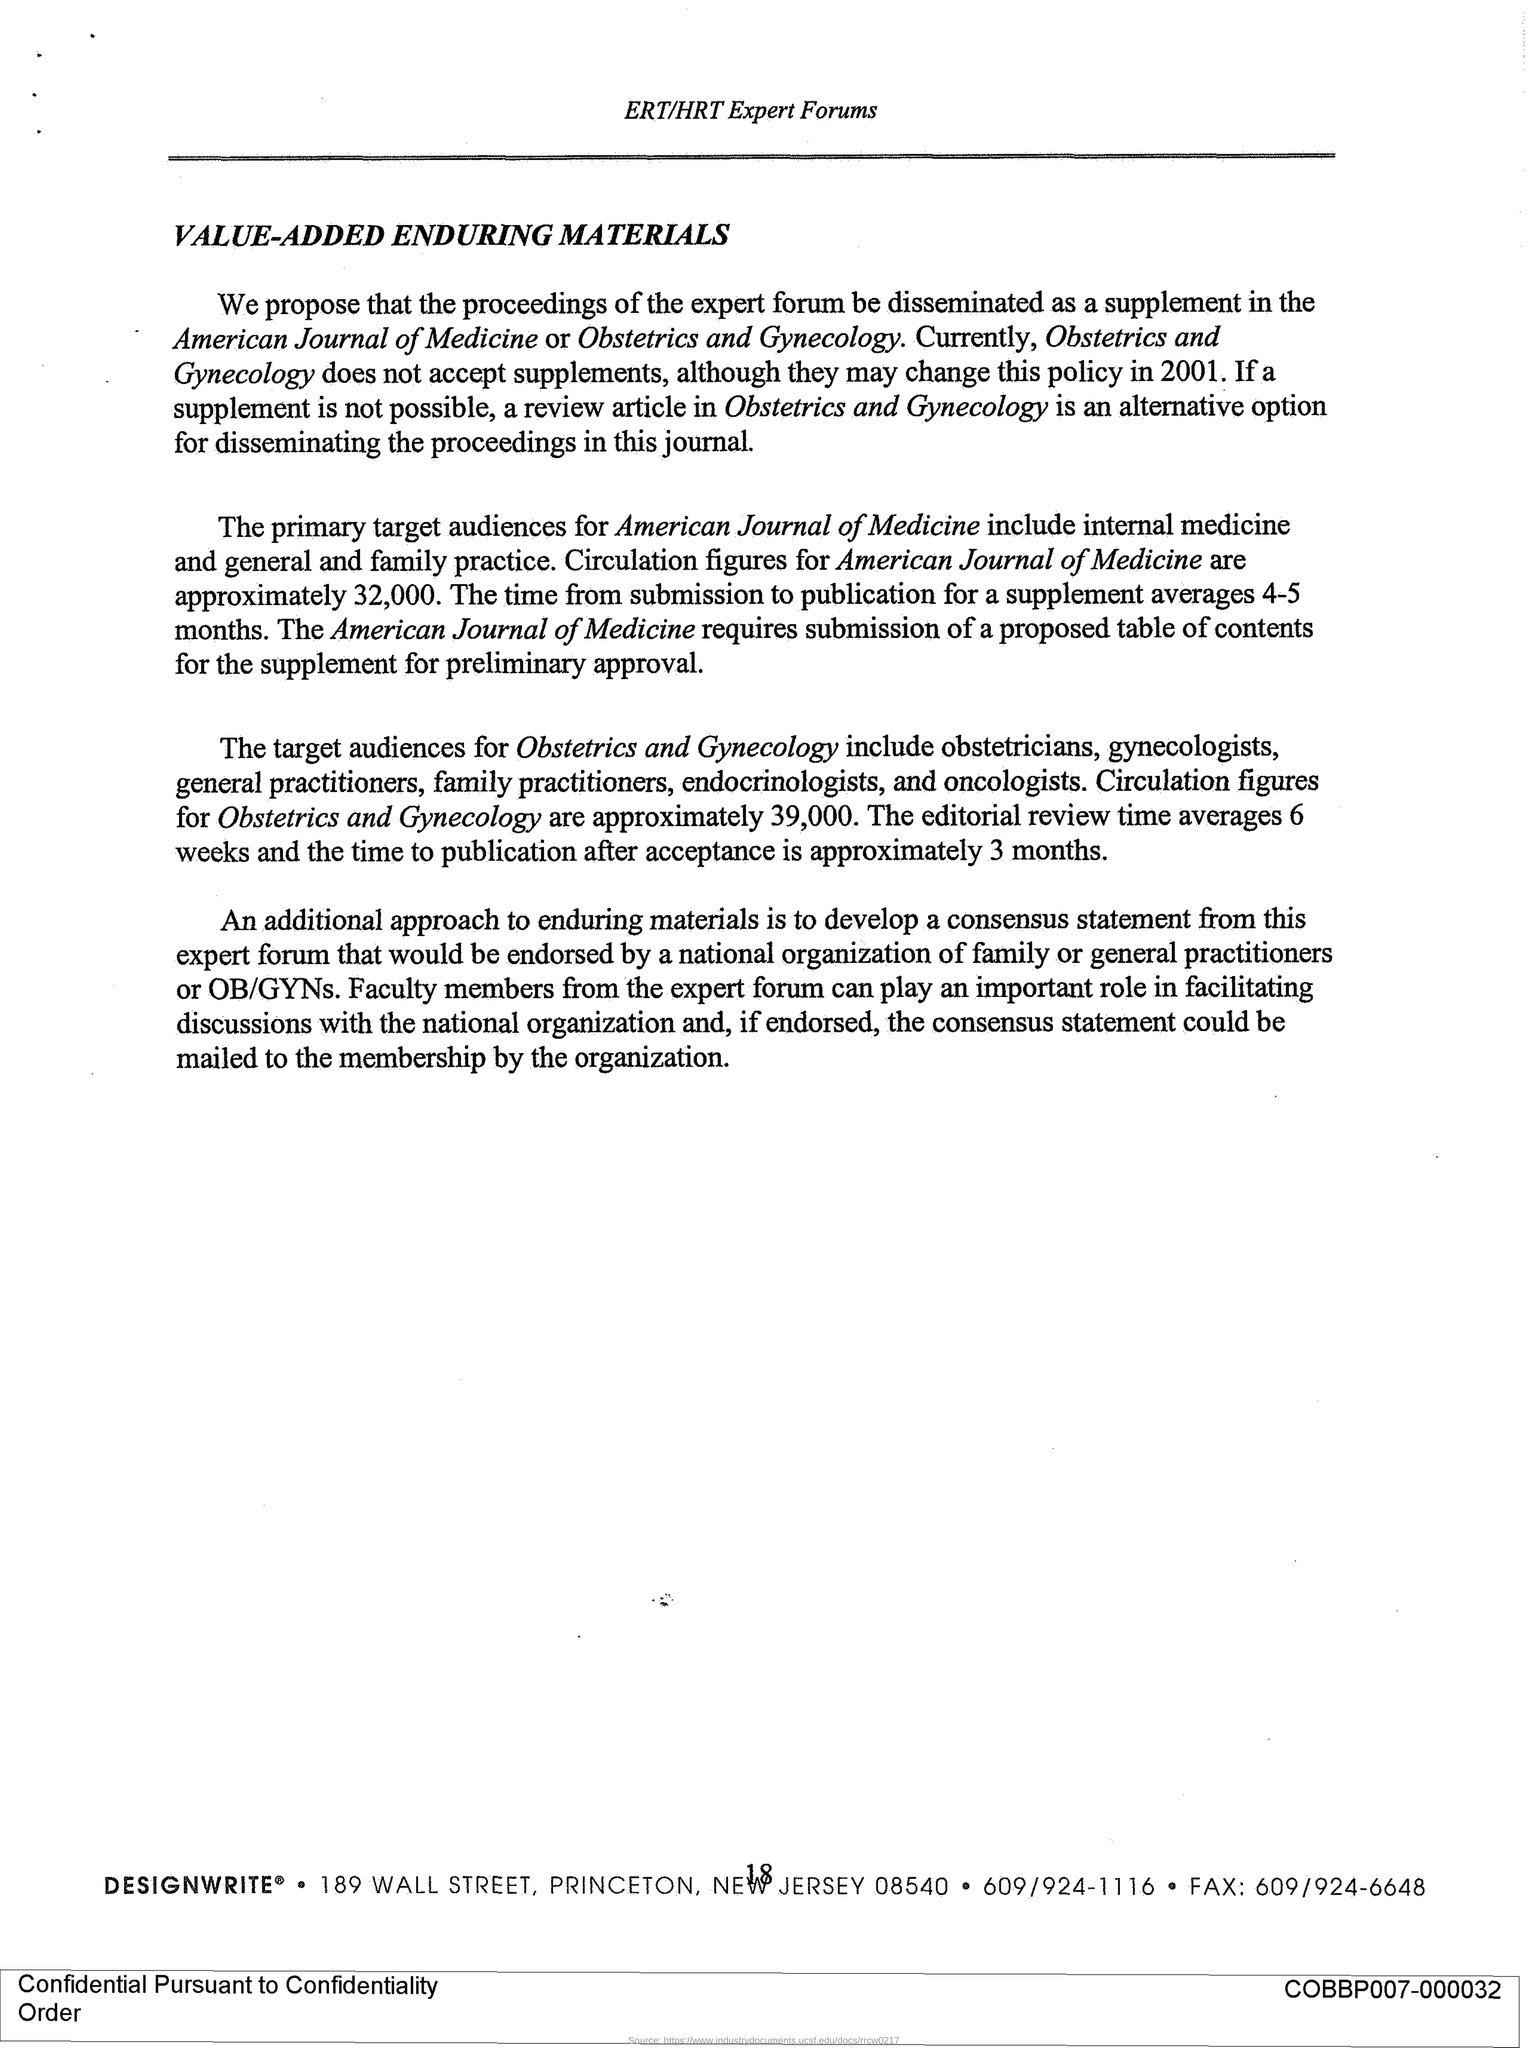Draw attention to some important aspects in this diagram. This document is titled VALUE-ADDED ENDURING MATERIALS. The ERT/HRT Expert Forums forum is mentioned in the header of the document. The average time from submission to publication for a supplement is approximately 4-5 months. The circulation figures for the American Journal of Medicine are approximately 32,000. 